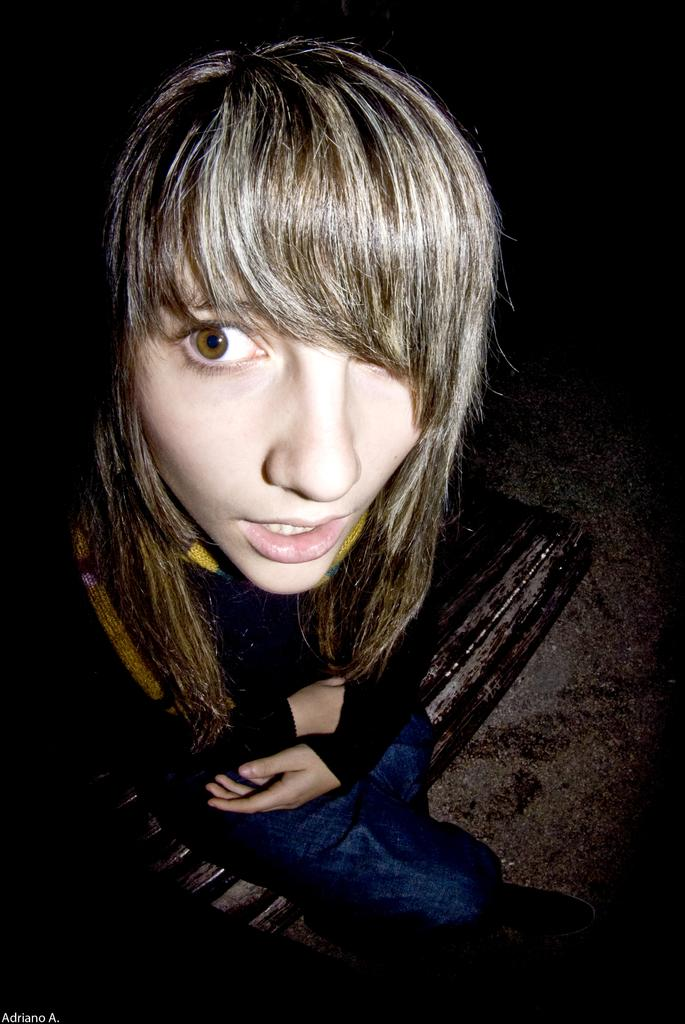Who is the main subject in the image? There is a girl in the image. What is the girl doing in the image? The girl is sitting. What color is the girl's top in the image? The girl is wearing a black top. What type of trousers is the girl wearing in the image? The girl is wearing jeans trousers. Can you see any bubbles floating around the girl in the image? There are no bubbles present in the image. 